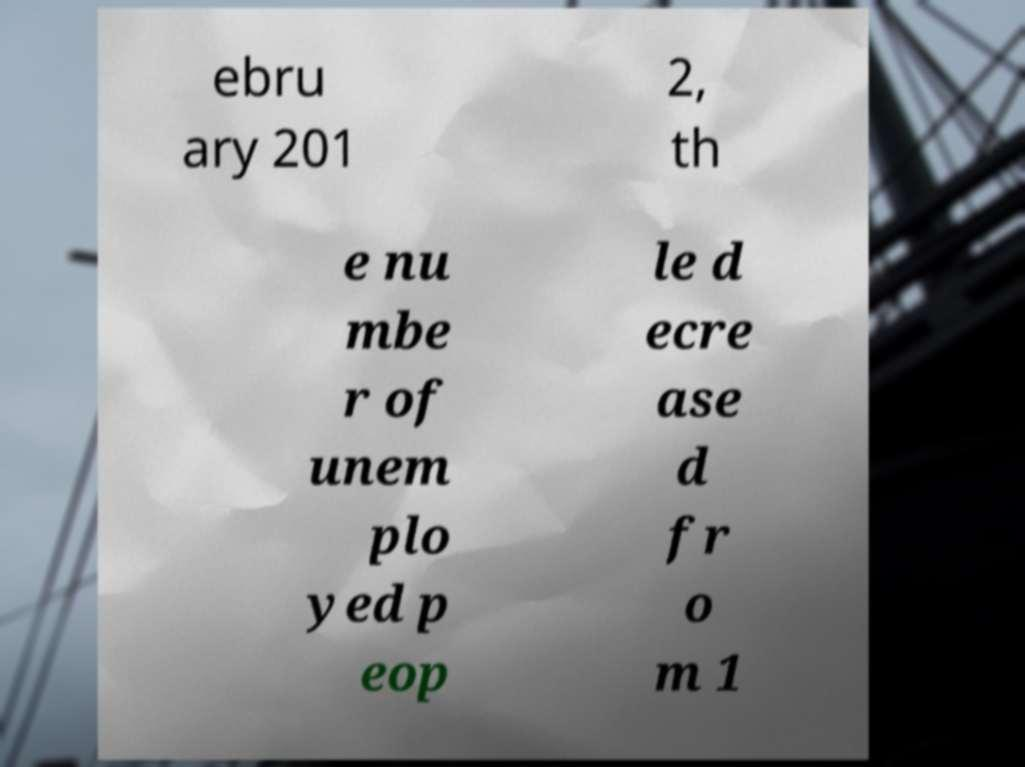There's text embedded in this image that I need extracted. Can you transcribe it verbatim? ebru ary 201 2, th e nu mbe r of unem plo yed p eop le d ecre ase d fr o m 1 